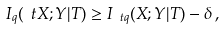Convert formula to latex. <formula><loc_0><loc_0><loc_500><loc_500>I _ { q } ( \ t X ; Y | T ) \geq I _ { \ t q } ( X ; Y | T ) - \delta \, ,</formula> 